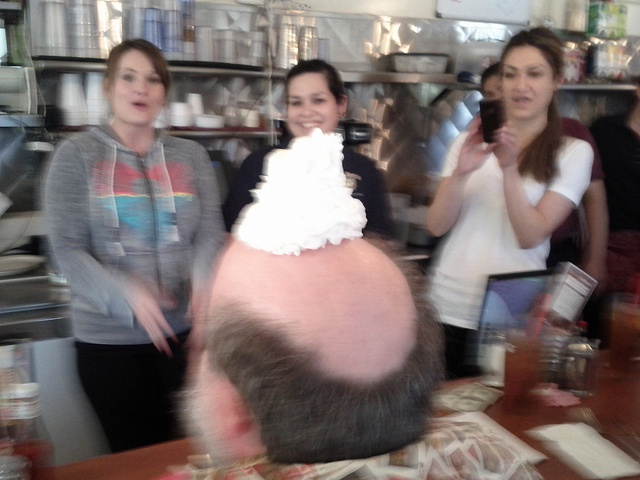Describe the objects in this image and their specific colors. I can see people in black, lightpink, darkgray, and gray tones, people in black and gray tones, people in black, darkgray, gray, and lightgray tones, dining table in black, maroon, gray, and brown tones, and people in black, darkgray, lightpink, and gray tones in this image. 